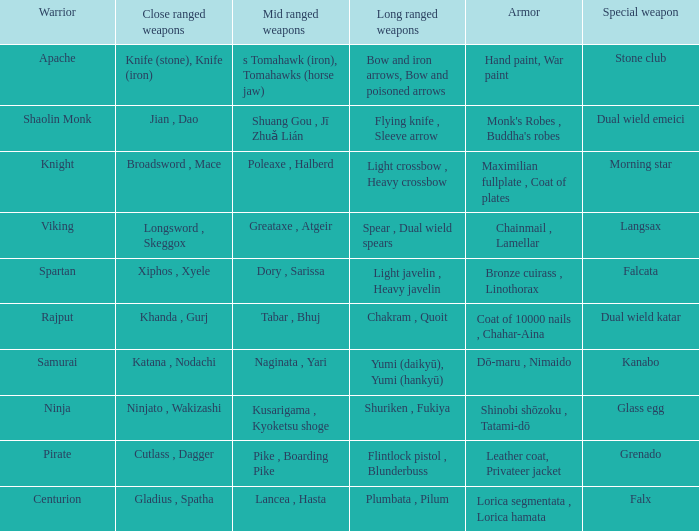If the armor is bronze cuirass , linothorax, what are the close ranged weapons? Xiphos , Xyele. 